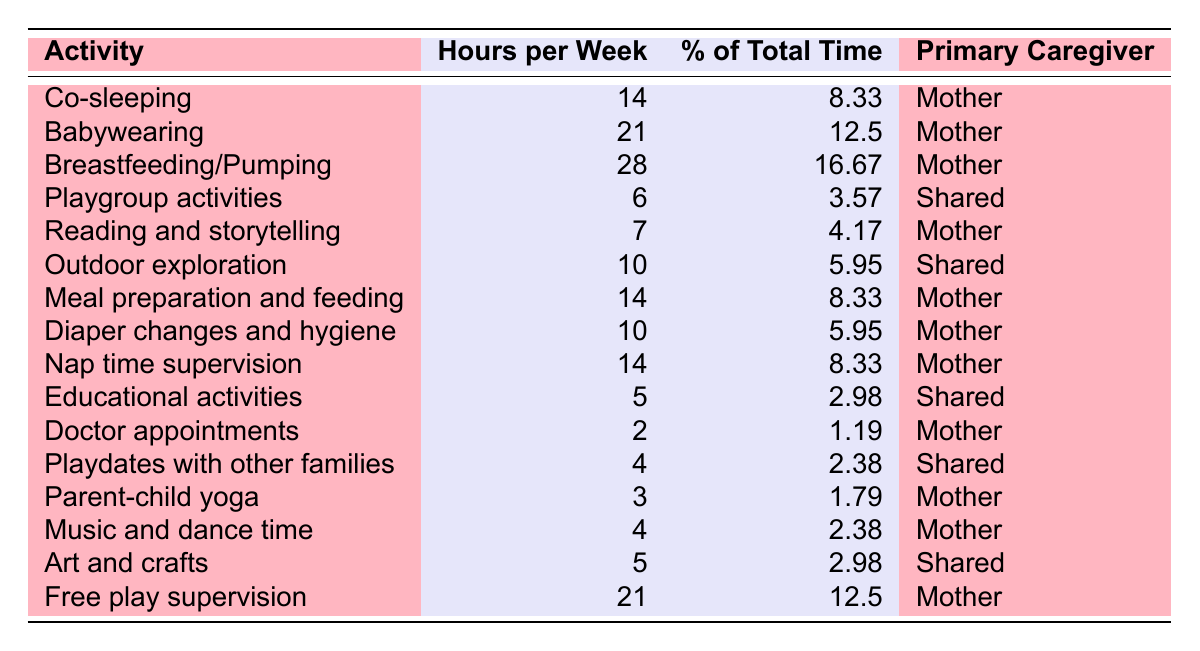What activity takes the most hours per week? Breastfeeding/Pumping has the highest value, which is 28 hours per week.
Answer: Breastfeeding/Pumping What percentage of time is spent on playgroup activities? Playgroup activities take up 3.57% of the total time based on the table.
Answer: 3.57% How many total hours are spent on mother-led activities? Adding up all the hours for mother-led activities: 14 (co-sleeping) + 21 (babywearing) + 28 (breastfeeding) + 7 (reading) + 14 (meal prep) + 10 (diaper changes) + 14 (nap supervision) + 2 (doctor appointments) + 3 (yoga) + 4 (music) + 21 (free play) gives a total of  14 + 21 + 28 + 7 + 14 + 10 + 14 + 2 + 3 + 4 + 21 =  144 hours.
Answer: 144 Which activity has the lowest hours per week? Doctor appointments take the lowest total with just 2 hours per week.
Answer: Doctor appointments Is the time allocated to outdoor exploration greater than that for educational activities? Outdoor exploration has 10 hours while educational activities have only 5 hours, thus yes, outdoor exploration is greater.
Answer: Yes What is the combined percentage of the total time spent on shared activities? The percentages for shared activities are: 3.57% (playgroup) + 5.95% (outdoor) + 2.98% (educational) + 2.38% (playdates) + 2.98% (arts and crafts) = 17.86%.
Answer: 17.86% Does the mother engage more in free play supervision than in any other single activity? Free play supervision takes 21 hours, which is more than any other single activity listed.
Answer: Yes If the mother adds 5 more hours to breastfeeding, what would be the new percentage of total time spent on it? New hours for breastfeeding would be 28 + 5 = 33 hours. The total hours would then be 5 + 5.95 + 2.98 + 3.57 + 2.38 + 4 + 4 + 10 + 21 + 14 + 14 + 6 + 7 + 2 + 3 + 10 + 21 = 150. The new percentage would be (33/150) * 100 = 22%.
Answer: 22% Which caregiver spends more time on parenting activities, the mother or shared activities? The total for the mother is 144 hours, while the shared activities total 30 hours, therefore the mother spends more time.
Answer: Mother How many more hours per week does the mother spend on babywearing compared to diaper changes? The mother spends 21 hours on babywearing and 10 hours on diaper changes. Thus, 21 - 10 = 11 more hours are spent on babywearing.
Answer: 11 